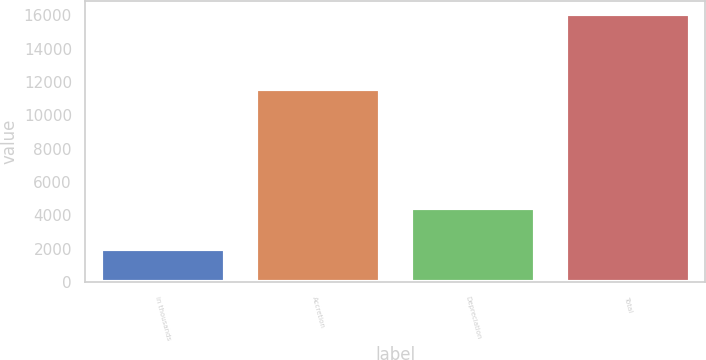Convert chart to OTSL. <chart><loc_0><loc_0><loc_500><loc_500><bar_chart><fcel>in thousands<fcel>Accretion<fcel>Depreciation<fcel>Total<nl><fcel>2014<fcel>11601<fcel>4462<fcel>16063<nl></chart> 